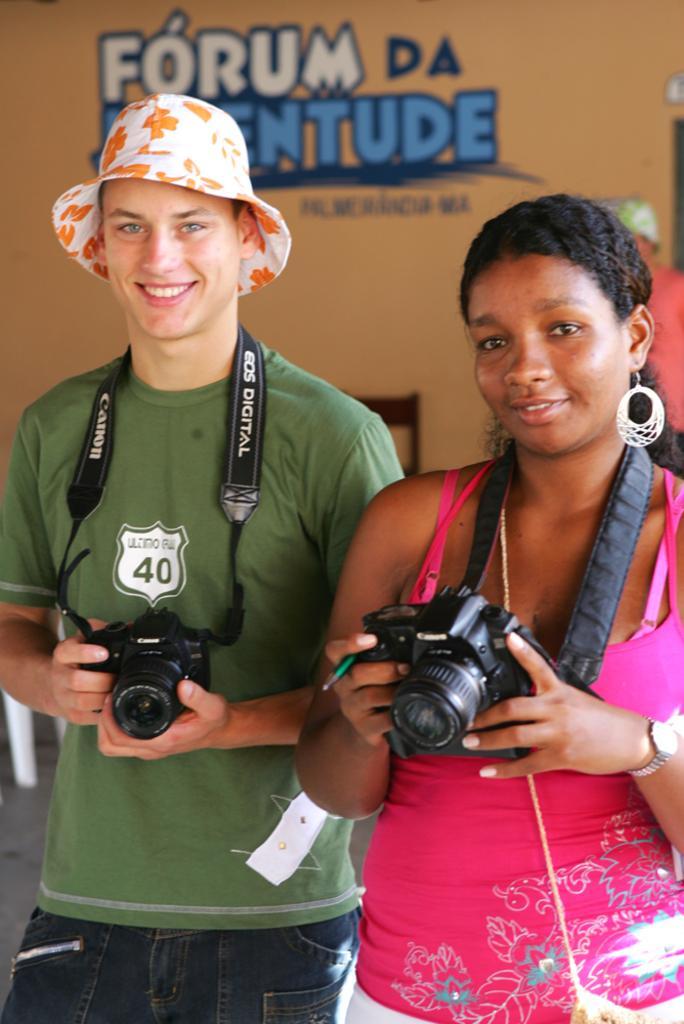Describe this image in one or two sentences. In this image there are two people standing and holding a camera. And a men who is wearing a green t shirt holding a camera and a woman wearing a pink color top holding a camera and in the background there is a wall which is in brown color 